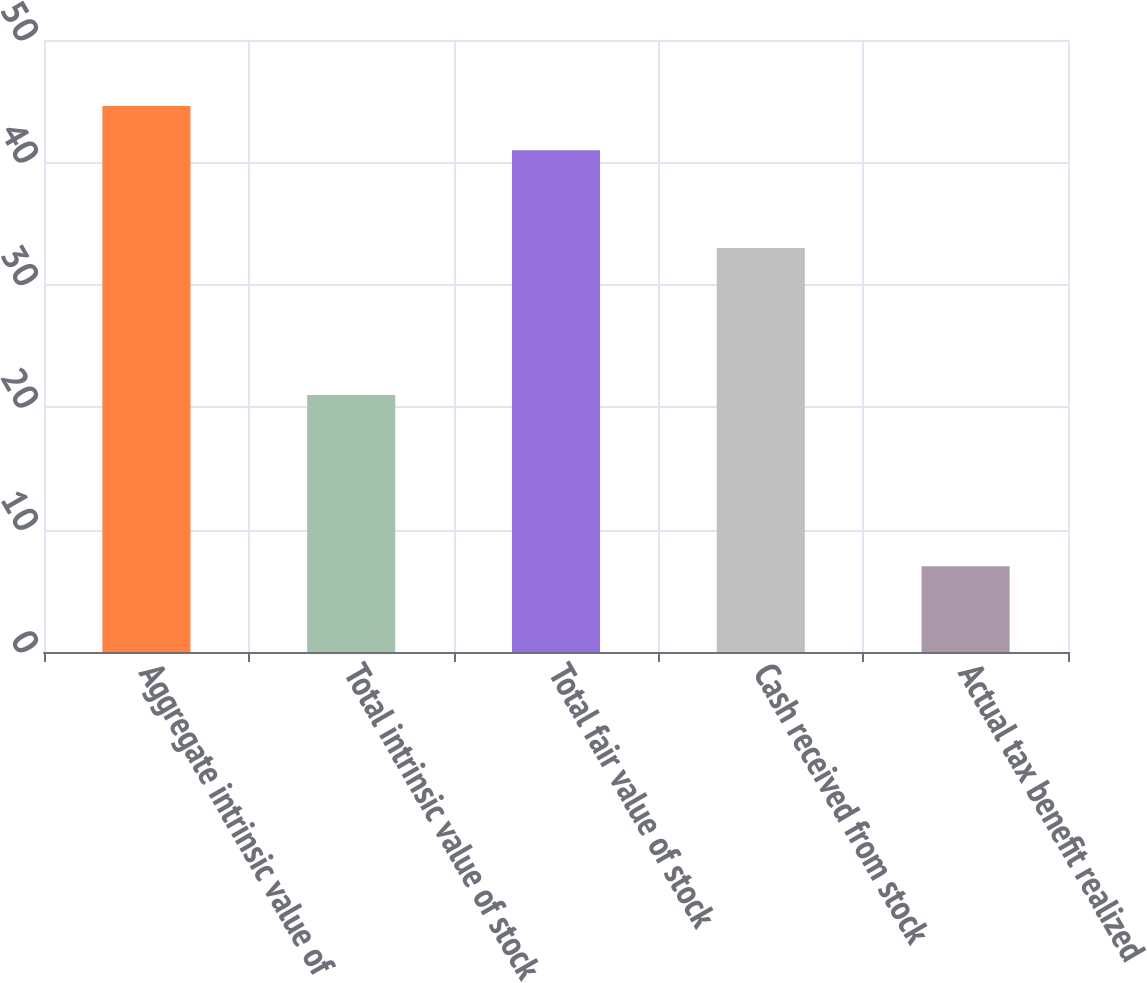<chart> <loc_0><loc_0><loc_500><loc_500><bar_chart><fcel>Aggregate intrinsic value of<fcel>Total intrinsic value of stock<fcel>Total fair value of stock<fcel>Cash received from stock<fcel>Actual tax benefit realized<nl><fcel>44.6<fcel>21<fcel>41<fcel>33<fcel>7<nl></chart> 